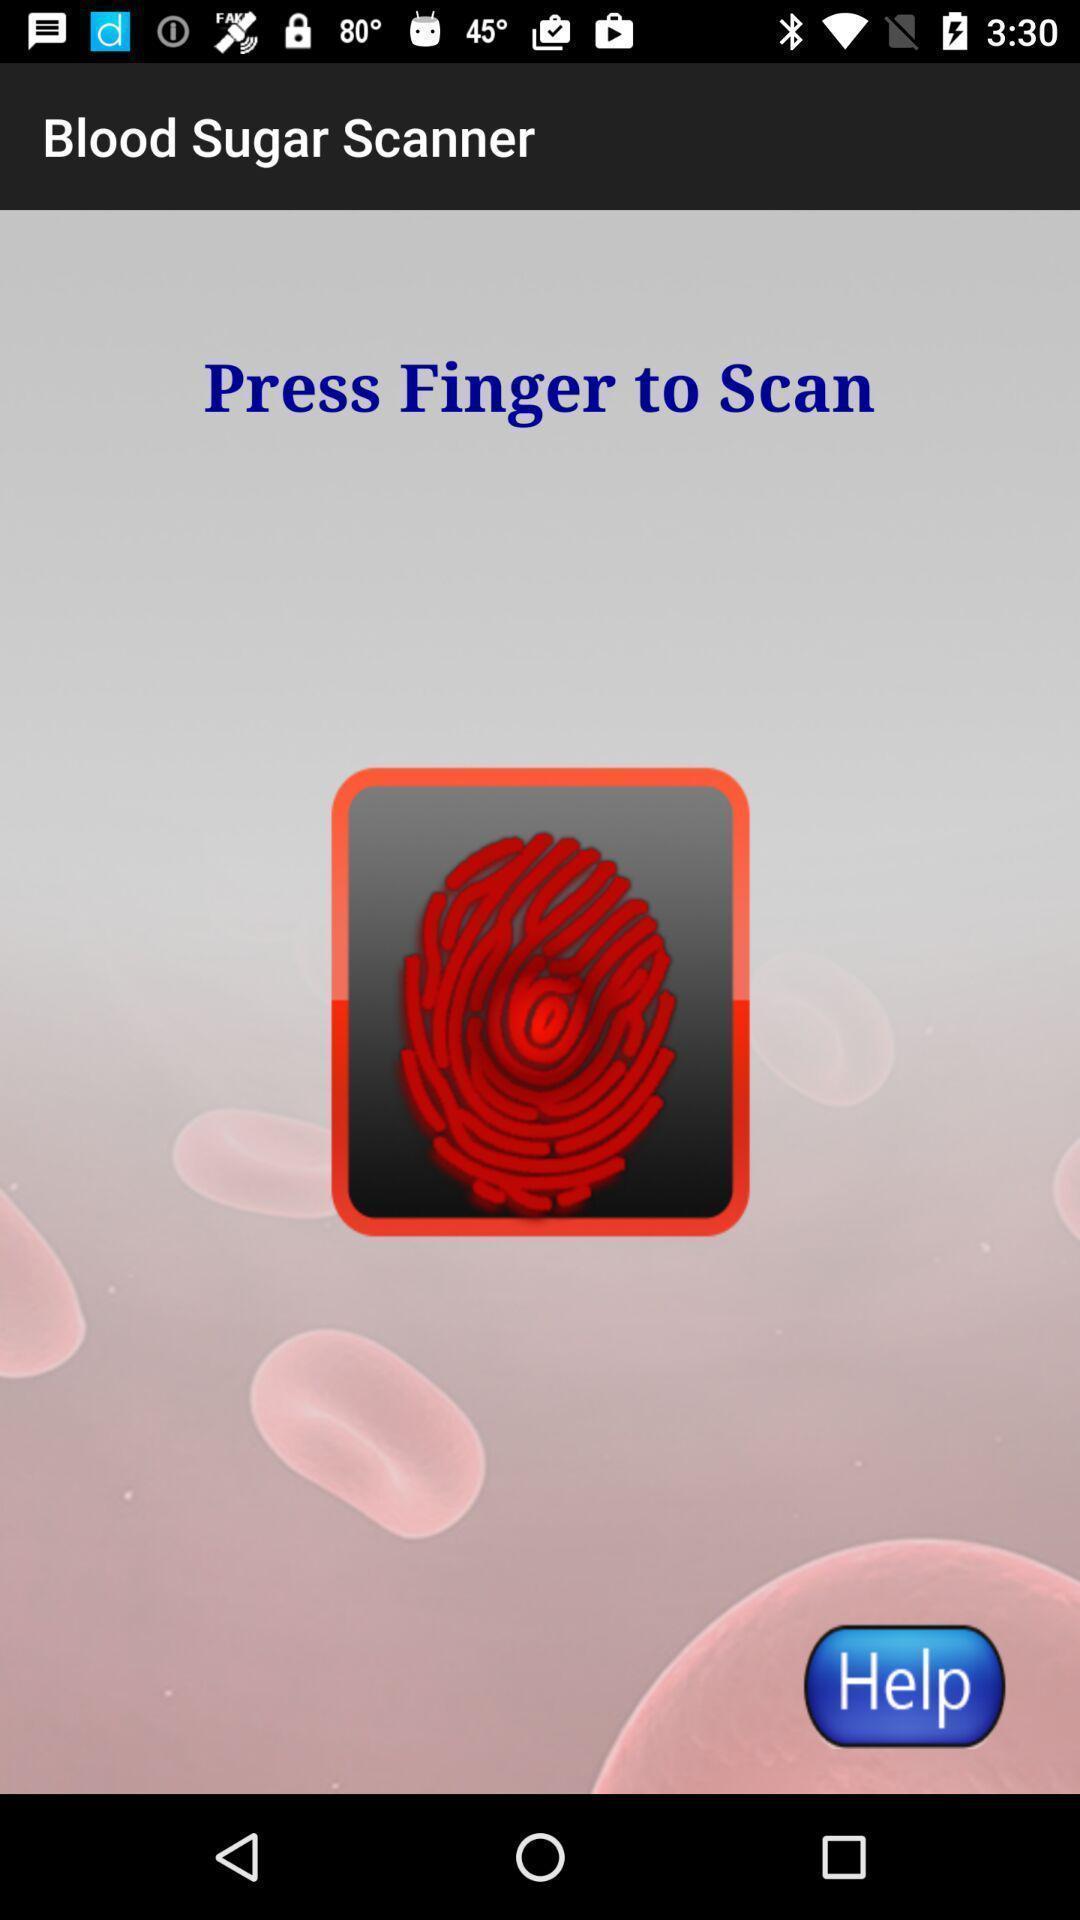Please provide a description for this image. Page displaying with scanner option for blood sugar. 